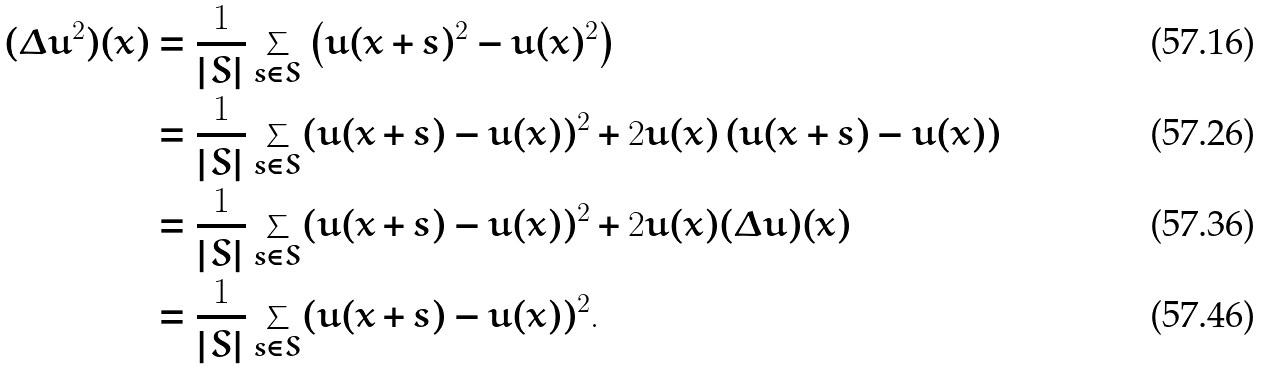<formula> <loc_0><loc_0><loc_500><loc_500>( \Delta u ^ { 2 } ) ( x ) & = \frac { 1 } { | S | } \sum _ { s \in S } \left ( u ( x + s ) ^ { 2 } - u ( x ) ^ { 2 } \right ) \\ & = \frac { 1 } { | S | } \sum _ { s \in S } ( u ( x + s ) - u ( x ) ) ^ { 2 } + 2 u ( x ) \left ( u ( x + s ) - u ( x ) \right ) \\ & = \frac { 1 } { | S | } \sum _ { s \in S } ( u ( x + s ) - u ( x ) ) ^ { 2 } + 2 u ( x ) ( \Delta u ) ( x ) \\ & = \frac { 1 } { | S | } \sum _ { s \in S } ( u ( x + s ) - u ( x ) ) ^ { 2 } .</formula> 